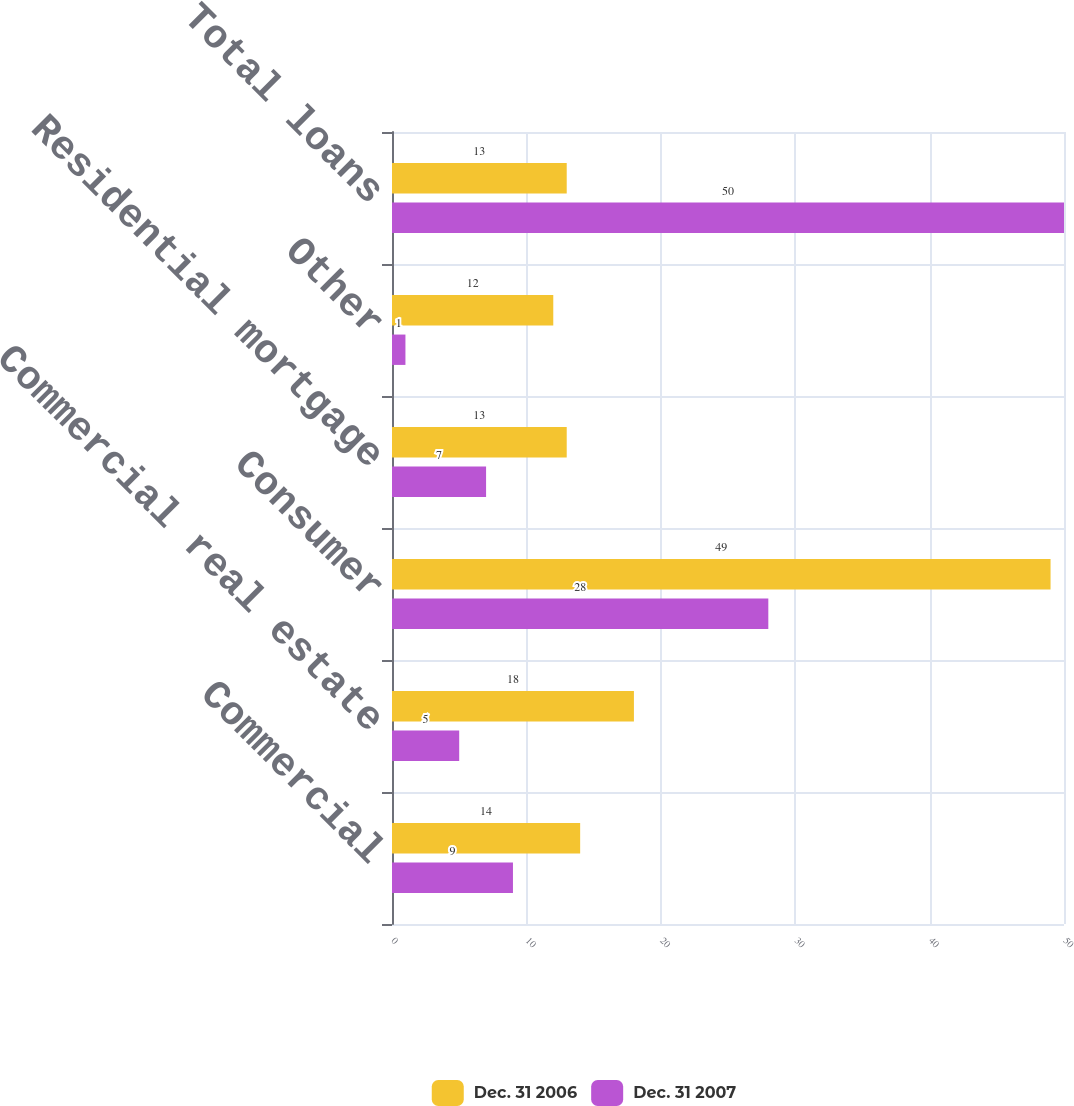Convert chart to OTSL. <chart><loc_0><loc_0><loc_500><loc_500><stacked_bar_chart><ecel><fcel>Commercial<fcel>Commercial real estate<fcel>Consumer<fcel>Residential mortgage<fcel>Other<fcel>Total loans<nl><fcel>Dec. 31 2006<fcel>14<fcel>18<fcel>49<fcel>13<fcel>12<fcel>13<nl><fcel>Dec. 31 2007<fcel>9<fcel>5<fcel>28<fcel>7<fcel>1<fcel>50<nl></chart> 